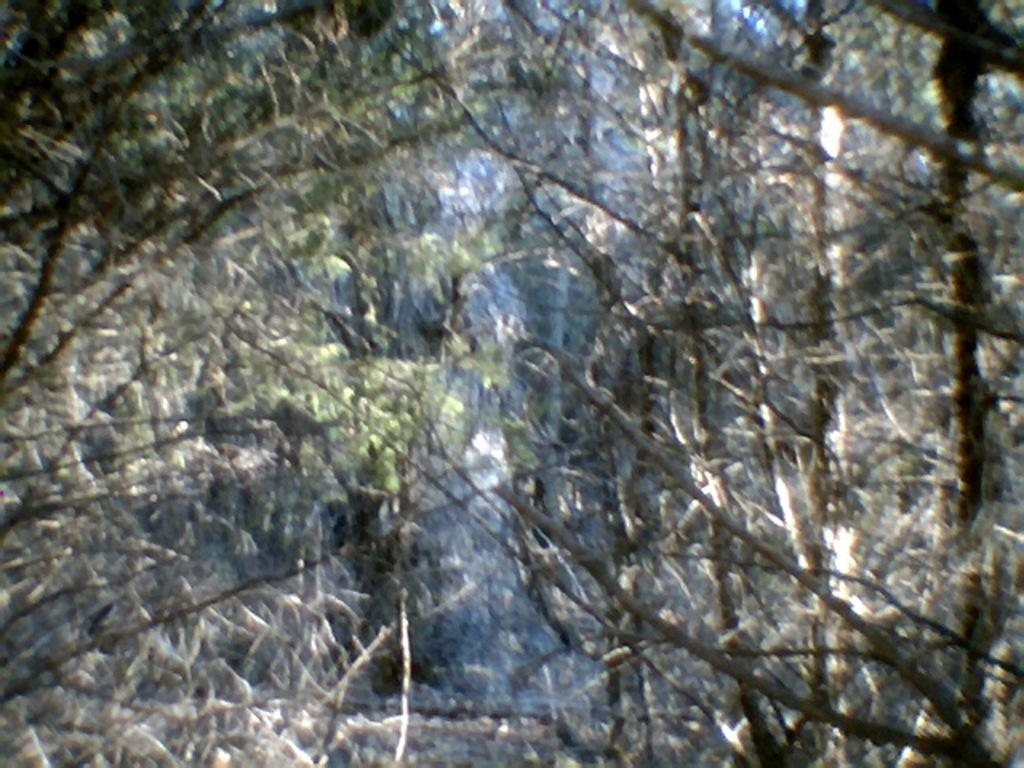What type of vegetation can be seen in the image? There are trees in the image. What is the desire of the nail on the border in the image? There is no nail or border present in the image, and therefore no such desire can be attributed. 